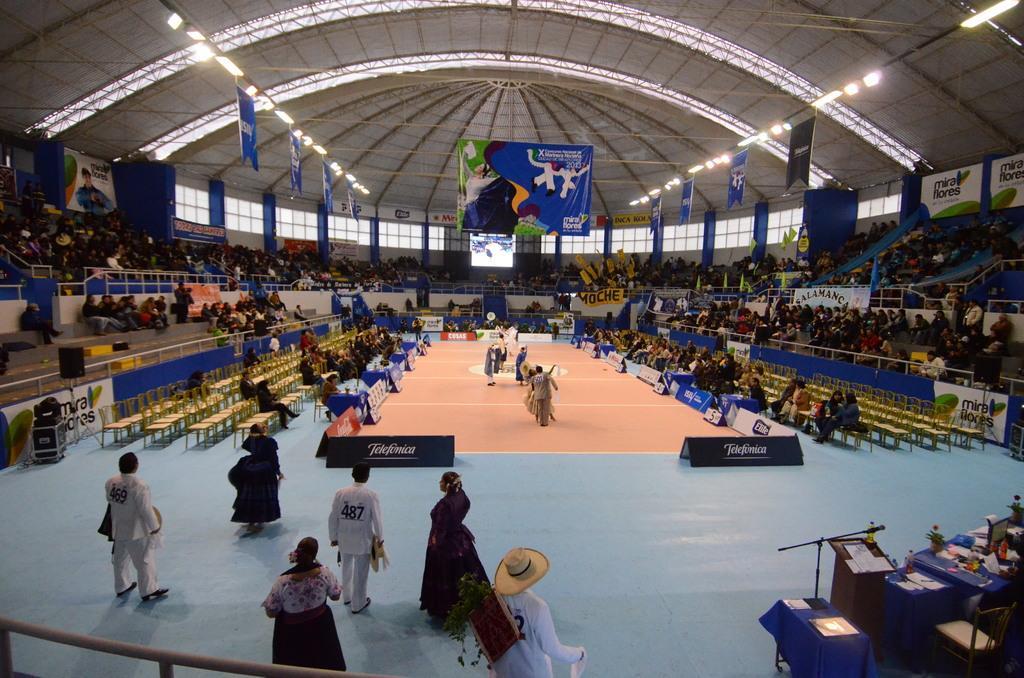Please provide a concise description of this image. In this image we can see people are sitting on the chairs and there are few people standing on the floor. Here we can see hoardings, banners, lights, roof, chairs, tables, clothes, mike, bottle, flower vases, and other objects. 